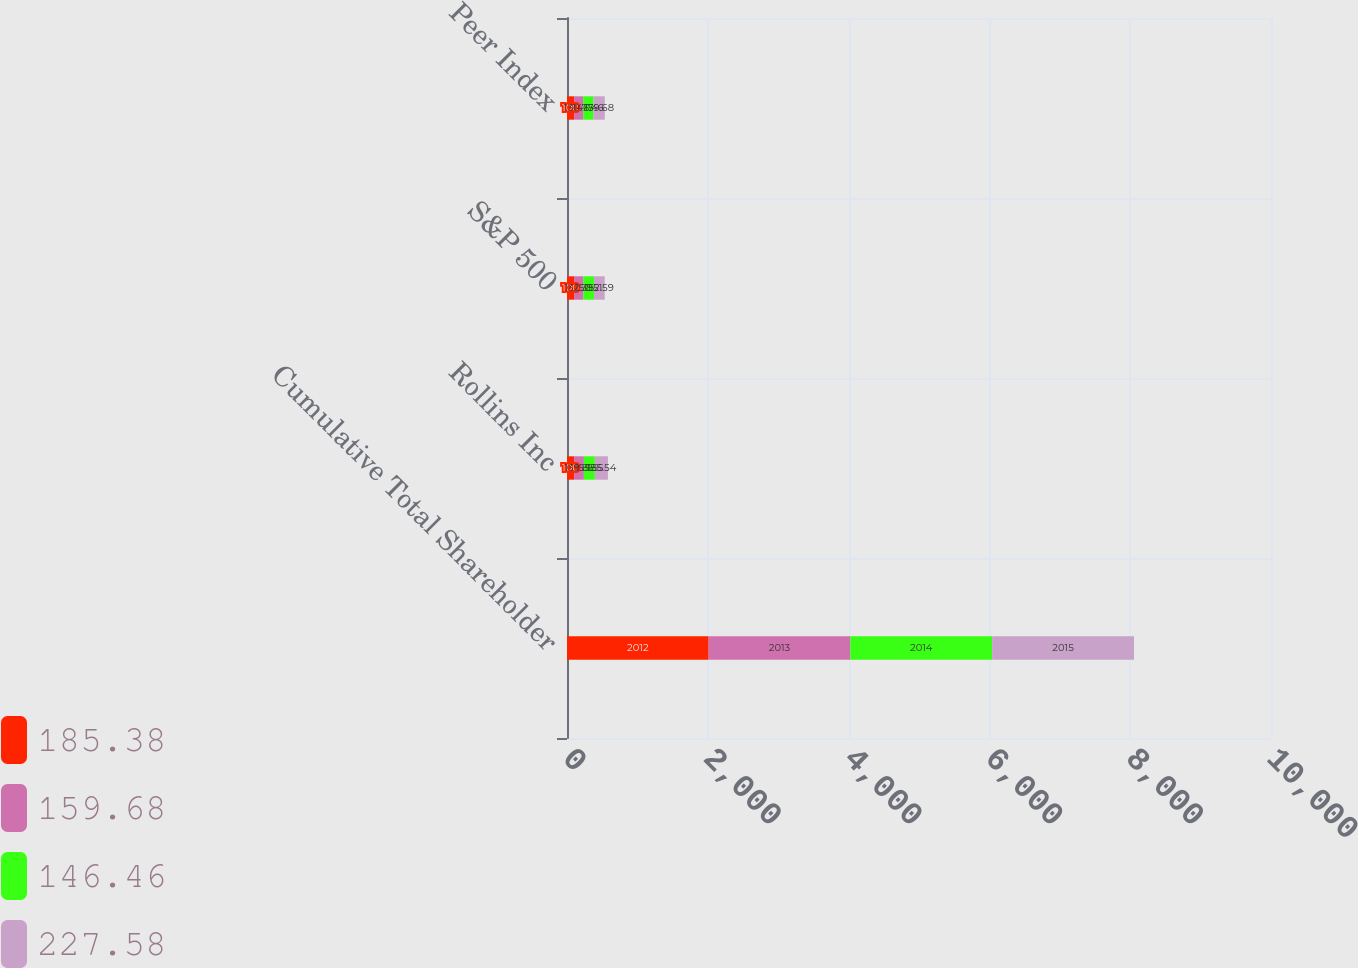Convert chart. <chart><loc_0><loc_0><loc_500><loc_500><stacked_bar_chart><ecel><fcel>Cumulative Total Shareholder<fcel>Rollins Inc<fcel>S&P 500<fcel>Peer Index<nl><fcel>185.38<fcel>2012<fcel>100<fcel>100<fcel>100<nl><fcel>159.68<fcel>2013<fcel>139.85<fcel>132.39<fcel>130.77<nl><fcel>146.46<fcel>2014<fcel>155.55<fcel>150.51<fcel>146.46<nl><fcel>227.58<fcel>2015<fcel>185.54<fcel>152.59<fcel>159.68<nl></chart> 